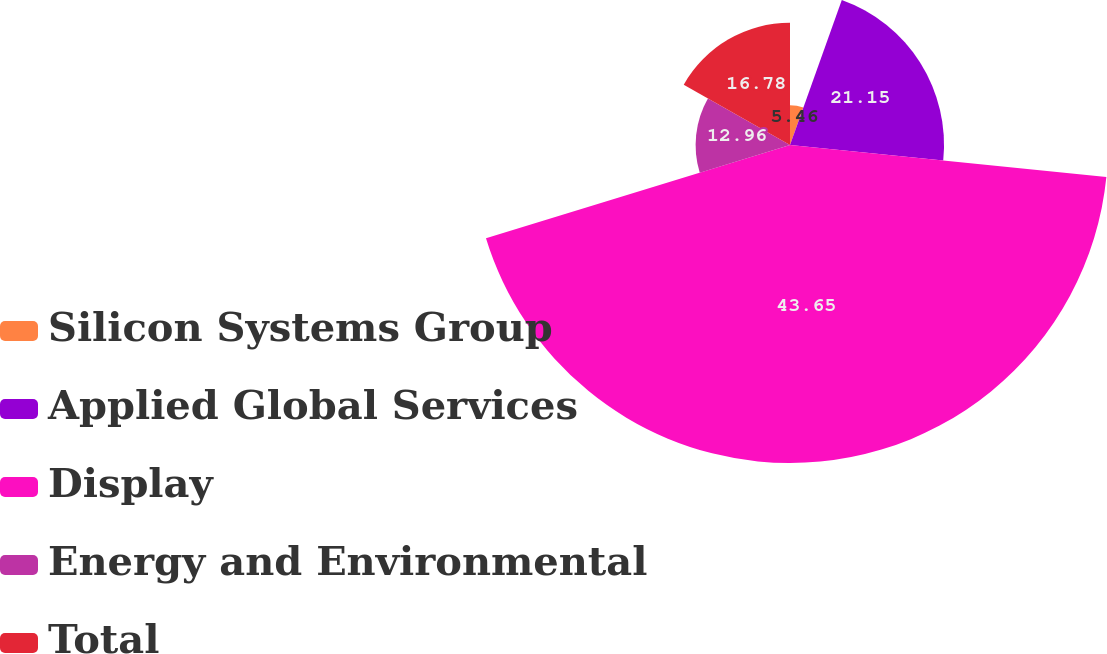<chart> <loc_0><loc_0><loc_500><loc_500><pie_chart><fcel>Silicon Systems Group<fcel>Applied Global Services<fcel>Display<fcel>Energy and Environmental<fcel>Total<nl><fcel>5.46%<fcel>21.15%<fcel>43.66%<fcel>12.96%<fcel>16.78%<nl></chart> 